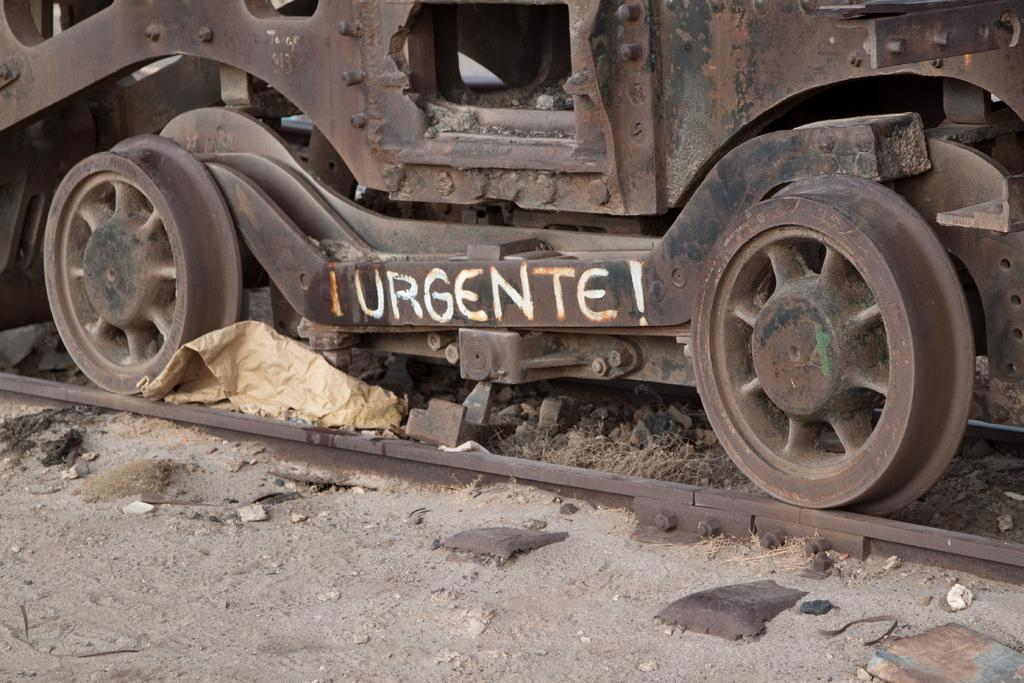What is the main subject of the image? The main subject of the image is a train. What is the train situated on in the image? The train is situated on a train track in the image. What is covering part of the image? There is a cover visible in the image. What type of text can be seen in the image? There is handwritten text in the image. What color is the sweater worn by the train in the image? There is no sweater present in the image, as trains do not wear clothing. 